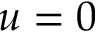<formula> <loc_0><loc_0><loc_500><loc_500>u = 0</formula> 